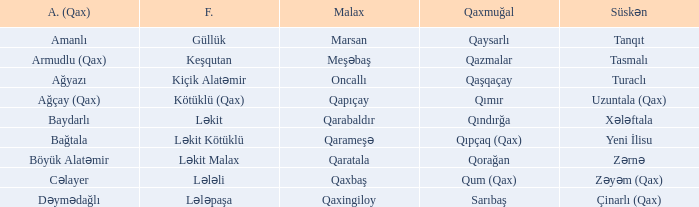What is the Almali village with the Süskən village zərnə? Böyük Alatəmir. 